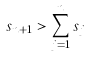<formula> <loc_0><loc_0><loc_500><loc_500>s _ { n + 1 } > \sum _ { j = 1 } ^ { n } s _ { j }</formula> 